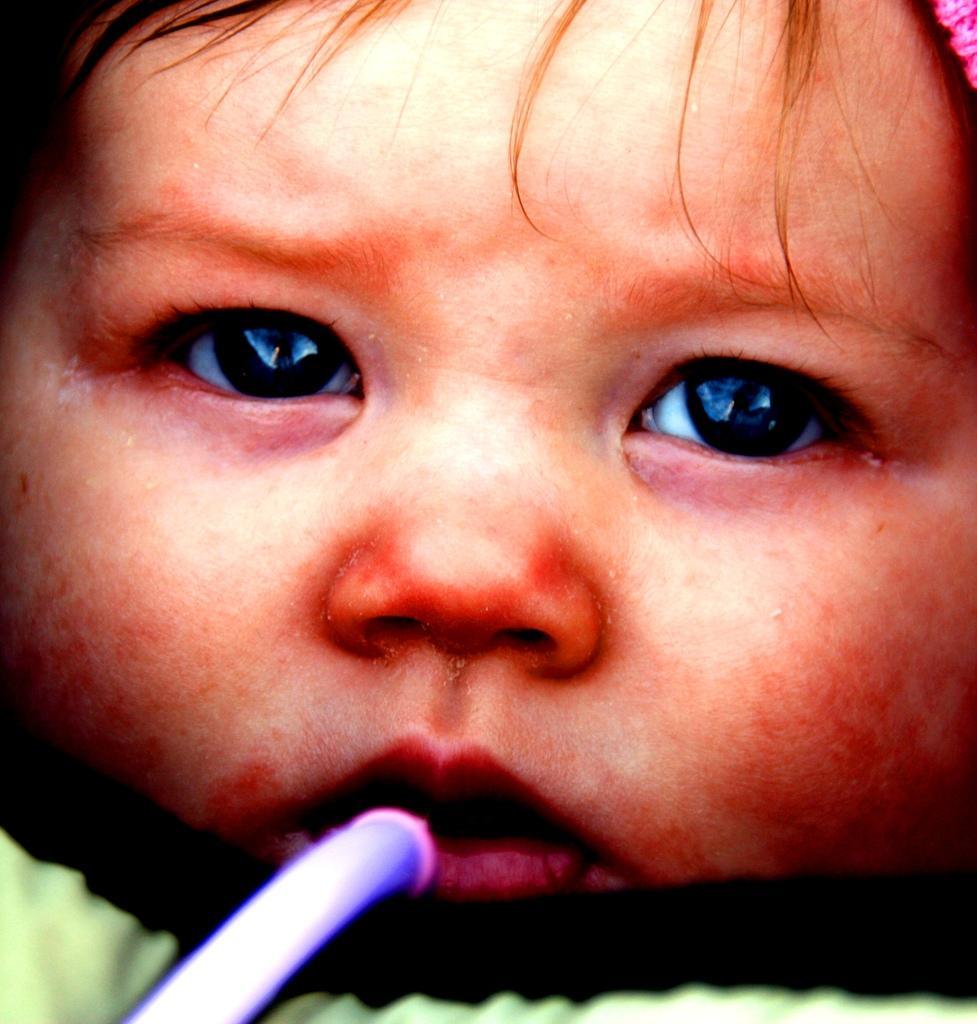In one or two sentences, can you explain what this image depicts? In this image we can see a baby and a straw in her mouth. 